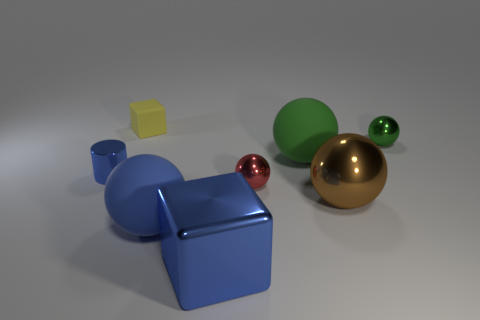There is a cylinder that is the same color as the large cube; what material is it?
Make the answer very short. Metal. What is the size of the metallic thing that is the same color as the shiny cylinder?
Your answer should be very brief. Large. How many things are either tiny blue shiny objects or big spheres behind the tiny red shiny object?
Ensure brevity in your answer.  2. The green object that is the same material as the red thing is what size?
Provide a succinct answer. Small. The small metal thing in front of the small metallic thing that is to the left of the metallic block is what shape?
Provide a succinct answer. Sphere. What number of red things are either things or small matte cylinders?
Keep it short and to the point. 1. Is there a metallic object to the left of the block behind the small sphere in front of the tiny cylinder?
Provide a short and direct response. Yes. There is a metallic object that is the same color as the metallic cube; what shape is it?
Your response must be concise. Cylinder. Is there any other thing that is the same material as the small green thing?
Provide a short and direct response. Yes. What number of big objects are cyan blocks or spheres?
Your answer should be compact. 3. 